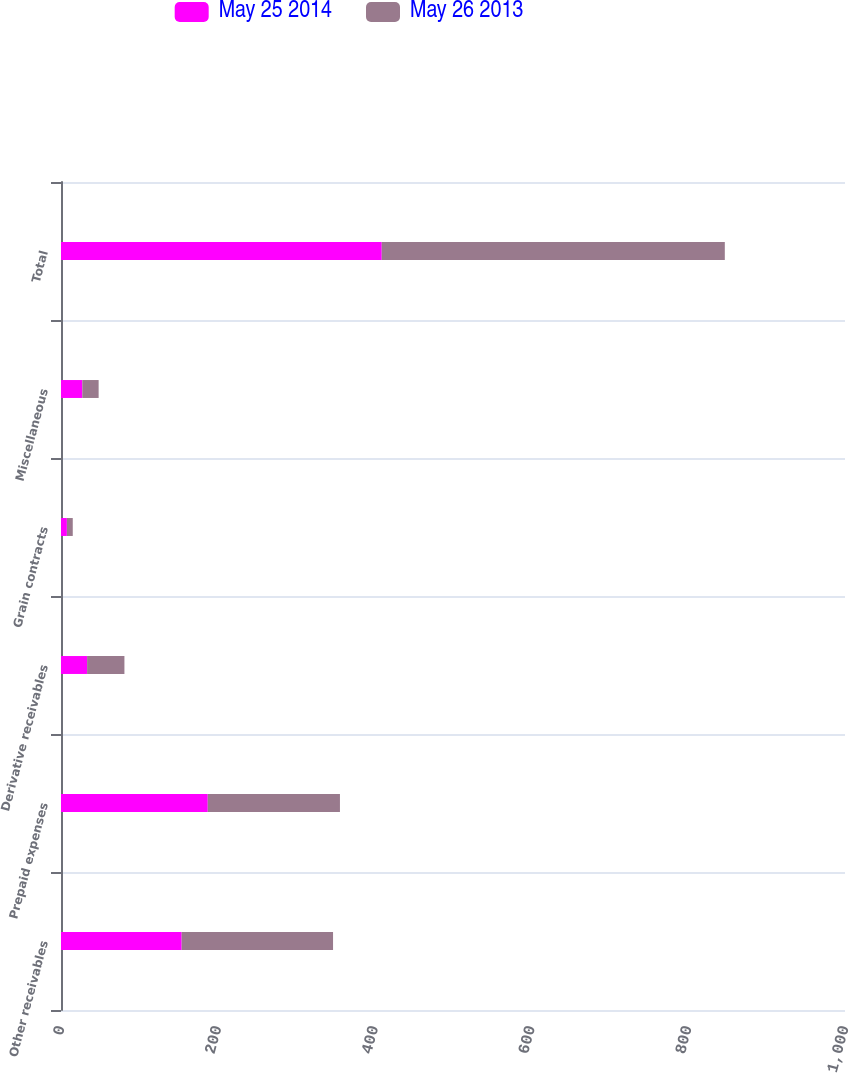Convert chart to OTSL. <chart><loc_0><loc_0><loc_500><loc_500><stacked_bar_chart><ecel><fcel>Other receivables<fcel>Prepaid expenses<fcel>Derivative receivables<fcel>Grain contracts<fcel>Miscellaneous<fcel>Total<nl><fcel>May 25 2014<fcel>153.9<fcel>187.2<fcel>33.3<fcel>7.5<fcel>27.2<fcel>409.1<nl><fcel>May 26 2013<fcel>193.1<fcel>168.6<fcel>47.6<fcel>7.5<fcel>20.8<fcel>437.6<nl></chart> 